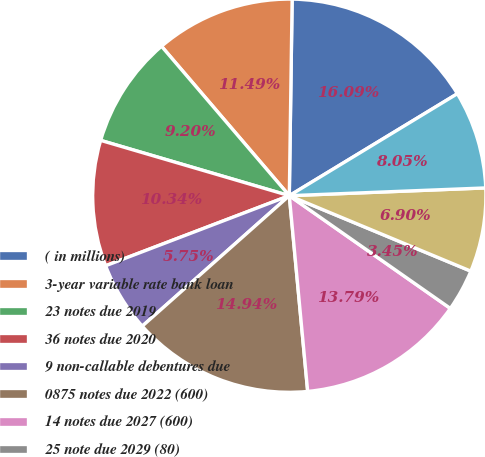Convert chart. <chart><loc_0><loc_0><loc_500><loc_500><pie_chart><fcel>( in millions)<fcel>3-year variable rate bank loan<fcel>23 notes due 2019<fcel>36 notes due 2020<fcel>9 non-callable debentures due<fcel>0875 notes due 2022 (600)<fcel>14 notes due 2027 (600)<fcel>25 note due 2029 (80)<fcel>770 notes due 2038<fcel>55 notes due 2040<nl><fcel>16.09%<fcel>11.49%<fcel>9.2%<fcel>10.34%<fcel>5.75%<fcel>14.94%<fcel>13.79%<fcel>3.45%<fcel>6.9%<fcel>8.05%<nl></chart> 